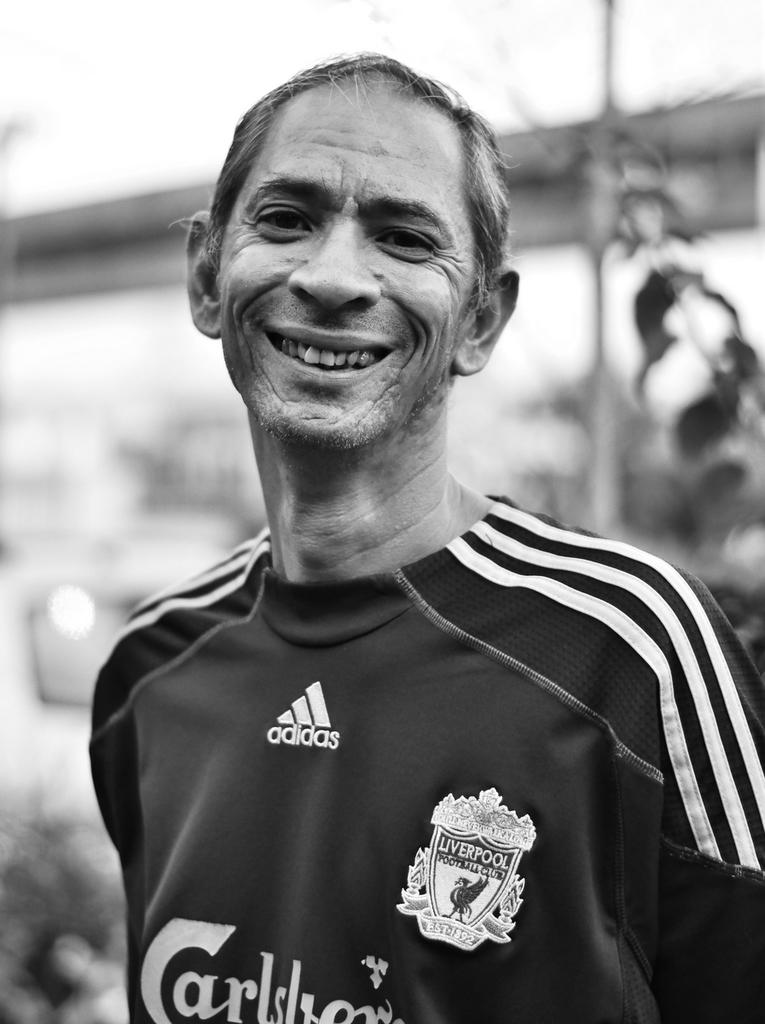Provide a one-sentence caption for the provided image. Liverpool Football Club soccer player smiling at camera. 